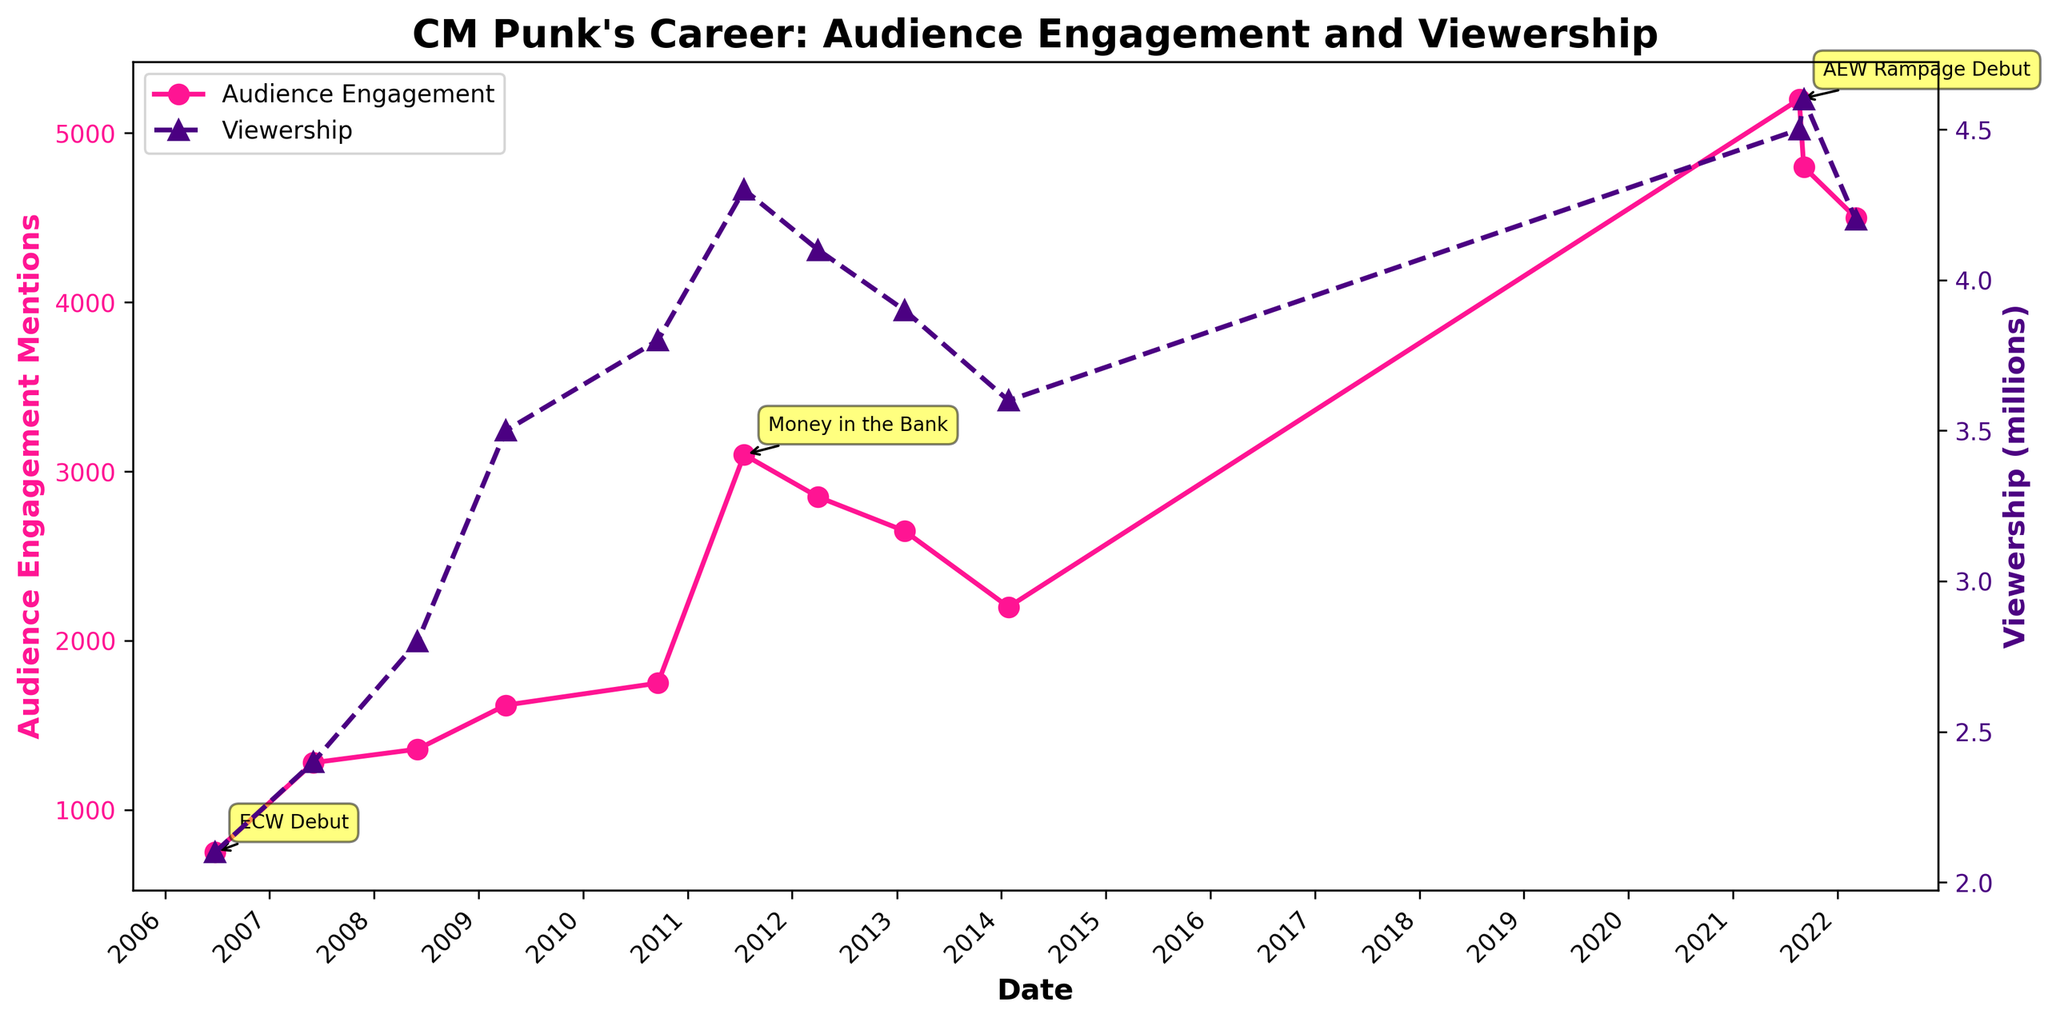When was CM Punk's AEW Rampage Debut event? The annotation on the plot next to the highest peak in audience engagement mentions AEW Rampage Debut with a date of 2021-08-20.
Answer: 2021-08-20 What are the two y-axes labels on the plot? The primary y-axis on the left is labeled "Audience Engagement Mentions," and the secondary y-axis on the right is labeled "Viewership (millions)."
Answer: Audience Engagement Mentions; Viewership (millions) Which matched event had the highest audience engagement mentions? The highest peak in audience engagement is annotated with the "AEW Rampage Debut" event in 2021-08-20.
Answer: AEW Rampage Debut What was CM Punk's last event before his AEW tenure in the figure? The figure shows "Royal Rumble" on 2014-01-26 for WWE, before CM Punk's return to AEW in 2021.
Answer: Royal Rumble (2014-01-26) By how much did the viewership increase from CM Punk's ECW Debut to Money in the Bank in 2011? The viewership at ECW Debut (2006-06-24) was 2.1 million, and at Money in the Bank (2011-07-17) it was 4.3 million; the increase is 4.3 - 2.1 = 2.2 million.
Answer: 2.2 million During which event did CM Punk see a significant increase in both audience engagement mentions and viewership compared to his previous events? The plot shows a significant increase at "Money in the Bank" in 2011, compared to previous events where both audience engagement mentions and viewership spiked considerably.
Answer: Money in the Bank (2011) How did the viewership trend change between CM Punk's debut and his appearance in AEW All Out in September 2021? The viewership shows a general increasing trend starting from 2.1 million at ECW Debut (2006) to 4.6 million at AEW All Out (2021).
Answer: It increased How do the audience engagement mentions at CM Punk's AEW Rampage Debut compare to his previous high at Money in the Bank? At AEW Rampage Debut, the audience engagement mentions reached 5200, while at Money in the Bank, it was 3100, which shows an increase of 5200 - 3100 = 2100 mentions.
Answer: 2100 more mentions What does the line pattern and marker type indicate for viewership on the plot? The viewership data is plotted with a dashed line and triangle markers, indicating different stylistic representation from the solid line and circular markers for audience engagement.
Answer: Dashed line and triangle markers Which event in the AEW timeline shows a decreasing trend in audience engagement mentions? In the AEW timeline, after AEW Rampage Debut (5200 mentions), there is a decrease in engagement mentions in AEW All Out (4800) and AEW Revolution (4500).
Answer: AEW Rampage Debut to AEW Revolution 